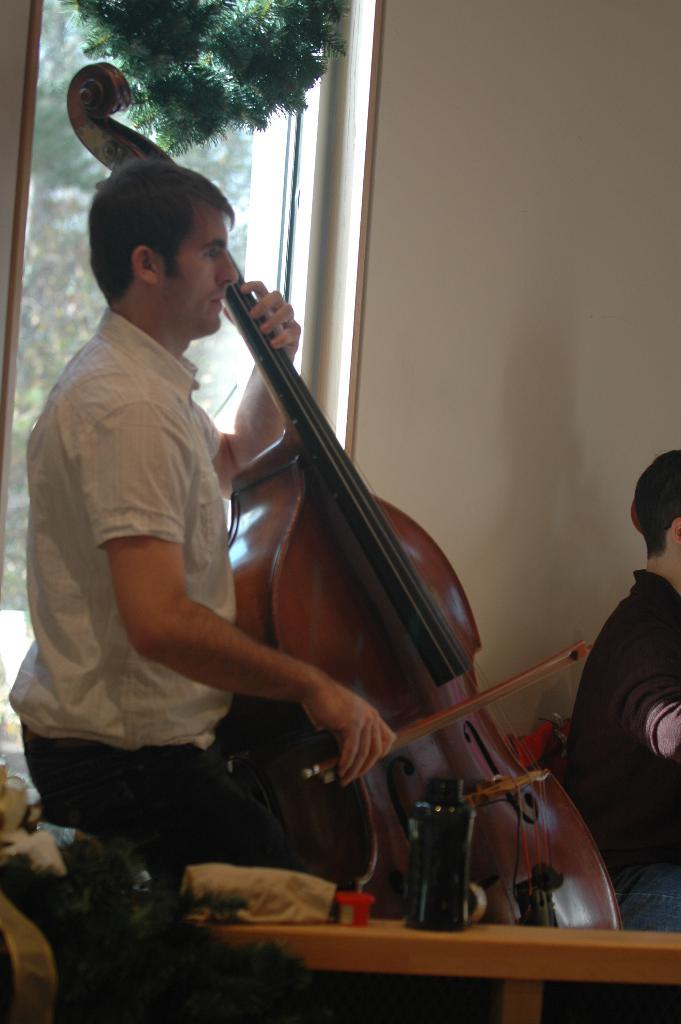What is the main activity being performed in the image? There is a person playing a violin in the image. Can you describe the person sitting in front of the violin player? There is a person sitting in front of the violin player, but no specific details about their appearance or actions are provided. What can be seen in the background of the image? There is a wall in the background of the image, and a glass door is visible on the wall. What type of pets are visible in the image? There are no pets visible in the image. Can you describe the conversation between the two people in the image? There is no conversation taking place between the two people in the image, as only one person is actively engaged in playing the violin. 